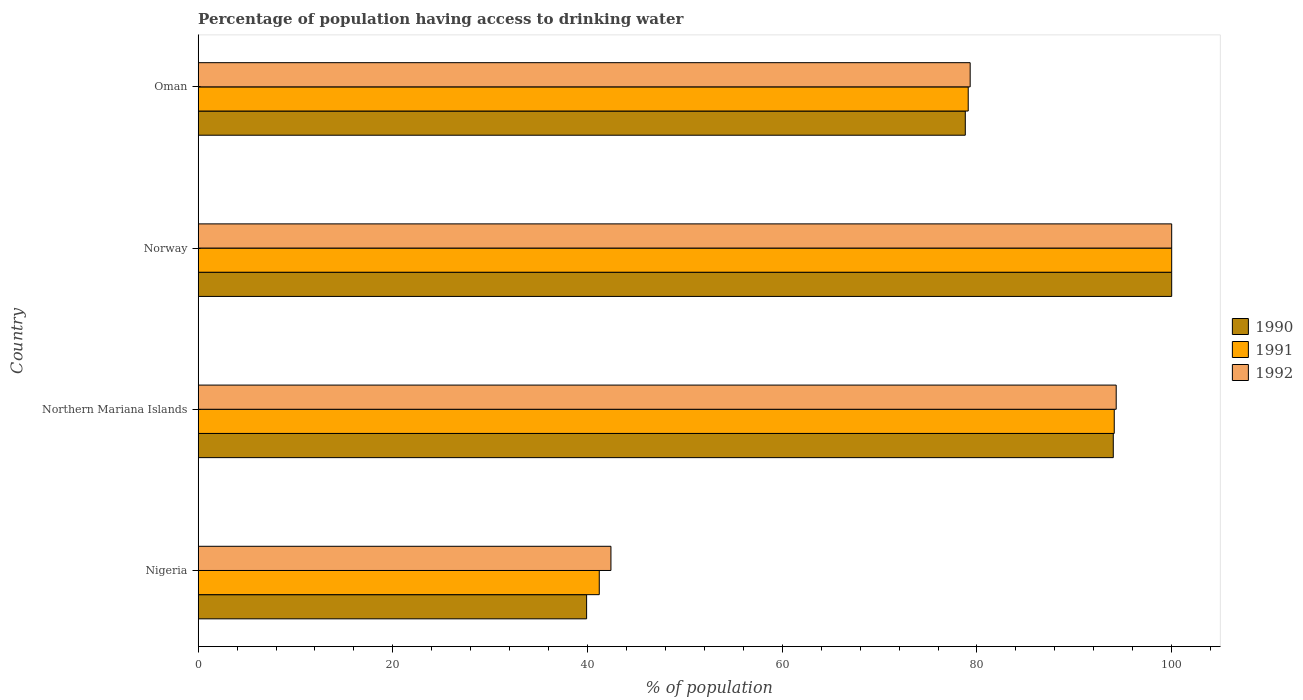How many different coloured bars are there?
Provide a succinct answer. 3. Are the number of bars per tick equal to the number of legend labels?
Give a very brief answer. Yes. How many bars are there on the 1st tick from the top?
Keep it short and to the point. 3. How many bars are there on the 3rd tick from the bottom?
Keep it short and to the point. 3. What is the label of the 3rd group of bars from the top?
Provide a succinct answer. Northern Mariana Islands. Across all countries, what is the maximum percentage of population having access to drinking water in 1992?
Provide a succinct answer. 100. Across all countries, what is the minimum percentage of population having access to drinking water in 1992?
Provide a short and direct response. 42.4. In which country was the percentage of population having access to drinking water in 1991 maximum?
Keep it short and to the point. Norway. In which country was the percentage of population having access to drinking water in 1991 minimum?
Offer a very short reply. Nigeria. What is the total percentage of population having access to drinking water in 1992 in the graph?
Your answer should be compact. 316. What is the difference between the percentage of population having access to drinking water in 1992 in Northern Mariana Islands and that in Oman?
Provide a succinct answer. 15. What is the difference between the percentage of population having access to drinking water in 1991 in Norway and the percentage of population having access to drinking water in 1990 in Oman?
Give a very brief answer. 21.2. What is the average percentage of population having access to drinking water in 1992 per country?
Your answer should be compact. 79. What is the difference between the percentage of population having access to drinking water in 1992 and percentage of population having access to drinking water in 1991 in Northern Mariana Islands?
Offer a very short reply. 0.2. In how many countries, is the percentage of population having access to drinking water in 1992 greater than 48 %?
Your response must be concise. 3. What is the ratio of the percentage of population having access to drinking water in 1990 in Norway to that in Oman?
Give a very brief answer. 1.27. Is the percentage of population having access to drinking water in 1990 in Nigeria less than that in Norway?
Make the answer very short. Yes. What is the difference between the highest and the second highest percentage of population having access to drinking water in 1991?
Your answer should be very brief. 5.9. What is the difference between the highest and the lowest percentage of population having access to drinking water in 1992?
Your response must be concise. 57.6. In how many countries, is the percentage of population having access to drinking water in 1992 greater than the average percentage of population having access to drinking water in 1992 taken over all countries?
Your response must be concise. 3. What does the 1st bar from the top in Oman represents?
Give a very brief answer. 1992. How many bars are there?
Make the answer very short. 12. Are all the bars in the graph horizontal?
Offer a terse response. Yes. How many countries are there in the graph?
Your answer should be very brief. 4. What is the difference between two consecutive major ticks on the X-axis?
Ensure brevity in your answer.  20. Are the values on the major ticks of X-axis written in scientific E-notation?
Provide a succinct answer. No. Does the graph contain any zero values?
Provide a short and direct response. No. How many legend labels are there?
Your answer should be very brief. 3. What is the title of the graph?
Ensure brevity in your answer.  Percentage of population having access to drinking water. What is the label or title of the X-axis?
Give a very brief answer. % of population. What is the % of population in 1990 in Nigeria?
Make the answer very short. 39.9. What is the % of population of 1991 in Nigeria?
Give a very brief answer. 41.2. What is the % of population of 1992 in Nigeria?
Offer a terse response. 42.4. What is the % of population of 1990 in Northern Mariana Islands?
Offer a very short reply. 94. What is the % of population of 1991 in Northern Mariana Islands?
Your answer should be compact. 94.1. What is the % of population of 1992 in Northern Mariana Islands?
Make the answer very short. 94.3. What is the % of population of 1990 in Norway?
Offer a very short reply. 100. What is the % of population in 1991 in Norway?
Your response must be concise. 100. What is the % of population in 1992 in Norway?
Your response must be concise. 100. What is the % of population in 1990 in Oman?
Your response must be concise. 78.8. What is the % of population in 1991 in Oman?
Your answer should be compact. 79.1. What is the % of population of 1992 in Oman?
Keep it short and to the point. 79.3. Across all countries, what is the maximum % of population of 1990?
Your response must be concise. 100. Across all countries, what is the minimum % of population in 1990?
Your answer should be very brief. 39.9. Across all countries, what is the minimum % of population of 1991?
Your answer should be compact. 41.2. Across all countries, what is the minimum % of population in 1992?
Your response must be concise. 42.4. What is the total % of population of 1990 in the graph?
Provide a short and direct response. 312.7. What is the total % of population in 1991 in the graph?
Give a very brief answer. 314.4. What is the total % of population of 1992 in the graph?
Ensure brevity in your answer.  316. What is the difference between the % of population in 1990 in Nigeria and that in Northern Mariana Islands?
Provide a succinct answer. -54.1. What is the difference between the % of population of 1991 in Nigeria and that in Northern Mariana Islands?
Your answer should be compact. -52.9. What is the difference between the % of population of 1992 in Nigeria and that in Northern Mariana Islands?
Provide a succinct answer. -51.9. What is the difference between the % of population in 1990 in Nigeria and that in Norway?
Offer a very short reply. -60.1. What is the difference between the % of population of 1991 in Nigeria and that in Norway?
Ensure brevity in your answer.  -58.8. What is the difference between the % of population in 1992 in Nigeria and that in Norway?
Offer a terse response. -57.6. What is the difference between the % of population in 1990 in Nigeria and that in Oman?
Your answer should be very brief. -38.9. What is the difference between the % of population in 1991 in Nigeria and that in Oman?
Offer a very short reply. -37.9. What is the difference between the % of population of 1992 in Nigeria and that in Oman?
Provide a short and direct response. -36.9. What is the difference between the % of population in 1991 in Northern Mariana Islands and that in Norway?
Your answer should be compact. -5.9. What is the difference between the % of population in 1990 in Northern Mariana Islands and that in Oman?
Provide a succinct answer. 15.2. What is the difference between the % of population of 1992 in Northern Mariana Islands and that in Oman?
Keep it short and to the point. 15. What is the difference between the % of population of 1990 in Norway and that in Oman?
Offer a very short reply. 21.2. What is the difference between the % of population of 1991 in Norway and that in Oman?
Make the answer very short. 20.9. What is the difference between the % of population of 1992 in Norway and that in Oman?
Offer a very short reply. 20.7. What is the difference between the % of population in 1990 in Nigeria and the % of population in 1991 in Northern Mariana Islands?
Ensure brevity in your answer.  -54.2. What is the difference between the % of population of 1990 in Nigeria and the % of population of 1992 in Northern Mariana Islands?
Make the answer very short. -54.4. What is the difference between the % of population in 1991 in Nigeria and the % of population in 1992 in Northern Mariana Islands?
Keep it short and to the point. -53.1. What is the difference between the % of population of 1990 in Nigeria and the % of population of 1991 in Norway?
Offer a terse response. -60.1. What is the difference between the % of population in 1990 in Nigeria and the % of population in 1992 in Norway?
Offer a terse response. -60.1. What is the difference between the % of population of 1991 in Nigeria and the % of population of 1992 in Norway?
Offer a terse response. -58.8. What is the difference between the % of population in 1990 in Nigeria and the % of population in 1991 in Oman?
Provide a short and direct response. -39.2. What is the difference between the % of population of 1990 in Nigeria and the % of population of 1992 in Oman?
Your answer should be very brief. -39.4. What is the difference between the % of population in 1991 in Nigeria and the % of population in 1992 in Oman?
Your answer should be compact. -38.1. What is the difference between the % of population in 1990 in Northern Mariana Islands and the % of population in 1991 in Norway?
Give a very brief answer. -6. What is the difference between the % of population of 1990 in Northern Mariana Islands and the % of population of 1992 in Norway?
Offer a very short reply. -6. What is the difference between the % of population in 1990 in Northern Mariana Islands and the % of population in 1991 in Oman?
Provide a succinct answer. 14.9. What is the difference between the % of population in 1990 in Northern Mariana Islands and the % of population in 1992 in Oman?
Provide a succinct answer. 14.7. What is the difference between the % of population in 1990 in Norway and the % of population in 1991 in Oman?
Offer a terse response. 20.9. What is the difference between the % of population in 1990 in Norway and the % of population in 1992 in Oman?
Offer a very short reply. 20.7. What is the difference between the % of population of 1991 in Norway and the % of population of 1992 in Oman?
Offer a terse response. 20.7. What is the average % of population in 1990 per country?
Provide a short and direct response. 78.17. What is the average % of population in 1991 per country?
Ensure brevity in your answer.  78.6. What is the average % of population in 1992 per country?
Give a very brief answer. 79. What is the difference between the % of population in 1991 and % of population in 1992 in Northern Mariana Islands?
Keep it short and to the point. -0.2. What is the difference between the % of population in 1990 and % of population in 1991 in Oman?
Ensure brevity in your answer.  -0.3. What is the difference between the % of population of 1990 and % of population of 1992 in Oman?
Give a very brief answer. -0.5. What is the difference between the % of population of 1991 and % of population of 1992 in Oman?
Offer a very short reply. -0.2. What is the ratio of the % of population in 1990 in Nigeria to that in Northern Mariana Islands?
Provide a succinct answer. 0.42. What is the ratio of the % of population in 1991 in Nigeria to that in Northern Mariana Islands?
Your answer should be very brief. 0.44. What is the ratio of the % of population of 1992 in Nigeria to that in Northern Mariana Islands?
Offer a very short reply. 0.45. What is the ratio of the % of population in 1990 in Nigeria to that in Norway?
Your answer should be very brief. 0.4. What is the ratio of the % of population of 1991 in Nigeria to that in Norway?
Ensure brevity in your answer.  0.41. What is the ratio of the % of population in 1992 in Nigeria to that in Norway?
Keep it short and to the point. 0.42. What is the ratio of the % of population of 1990 in Nigeria to that in Oman?
Ensure brevity in your answer.  0.51. What is the ratio of the % of population in 1991 in Nigeria to that in Oman?
Offer a very short reply. 0.52. What is the ratio of the % of population in 1992 in Nigeria to that in Oman?
Offer a terse response. 0.53. What is the ratio of the % of population in 1991 in Northern Mariana Islands to that in Norway?
Make the answer very short. 0.94. What is the ratio of the % of population of 1992 in Northern Mariana Islands to that in Norway?
Give a very brief answer. 0.94. What is the ratio of the % of population of 1990 in Northern Mariana Islands to that in Oman?
Provide a succinct answer. 1.19. What is the ratio of the % of population in 1991 in Northern Mariana Islands to that in Oman?
Ensure brevity in your answer.  1.19. What is the ratio of the % of population of 1992 in Northern Mariana Islands to that in Oman?
Give a very brief answer. 1.19. What is the ratio of the % of population of 1990 in Norway to that in Oman?
Ensure brevity in your answer.  1.27. What is the ratio of the % of population in 1991 in Norway to that in Oman?
Your answer should be very brief. 1.26. What is the ratio of the % of population in 1992 in Norway to that in Oman?
Ensure brevity in your answer.  1.26. What is the difference between the highest and the second highest % of population in 1991?
Keep it short and to the point. 5.9. What is the difference between the highest and the second highest % of population of 1992?
Offer a very short reply. 5.7. What is the difference between the highest and the lowest % of population of 1990?
Your response must be concise. 60.1. What is the difference between the highest and the lowest % of population in 1991?
Your response must be concise. 58.8. What is the difference between the highest and the lowest % of population in 1992?
Your response must be concise. 57.6. 